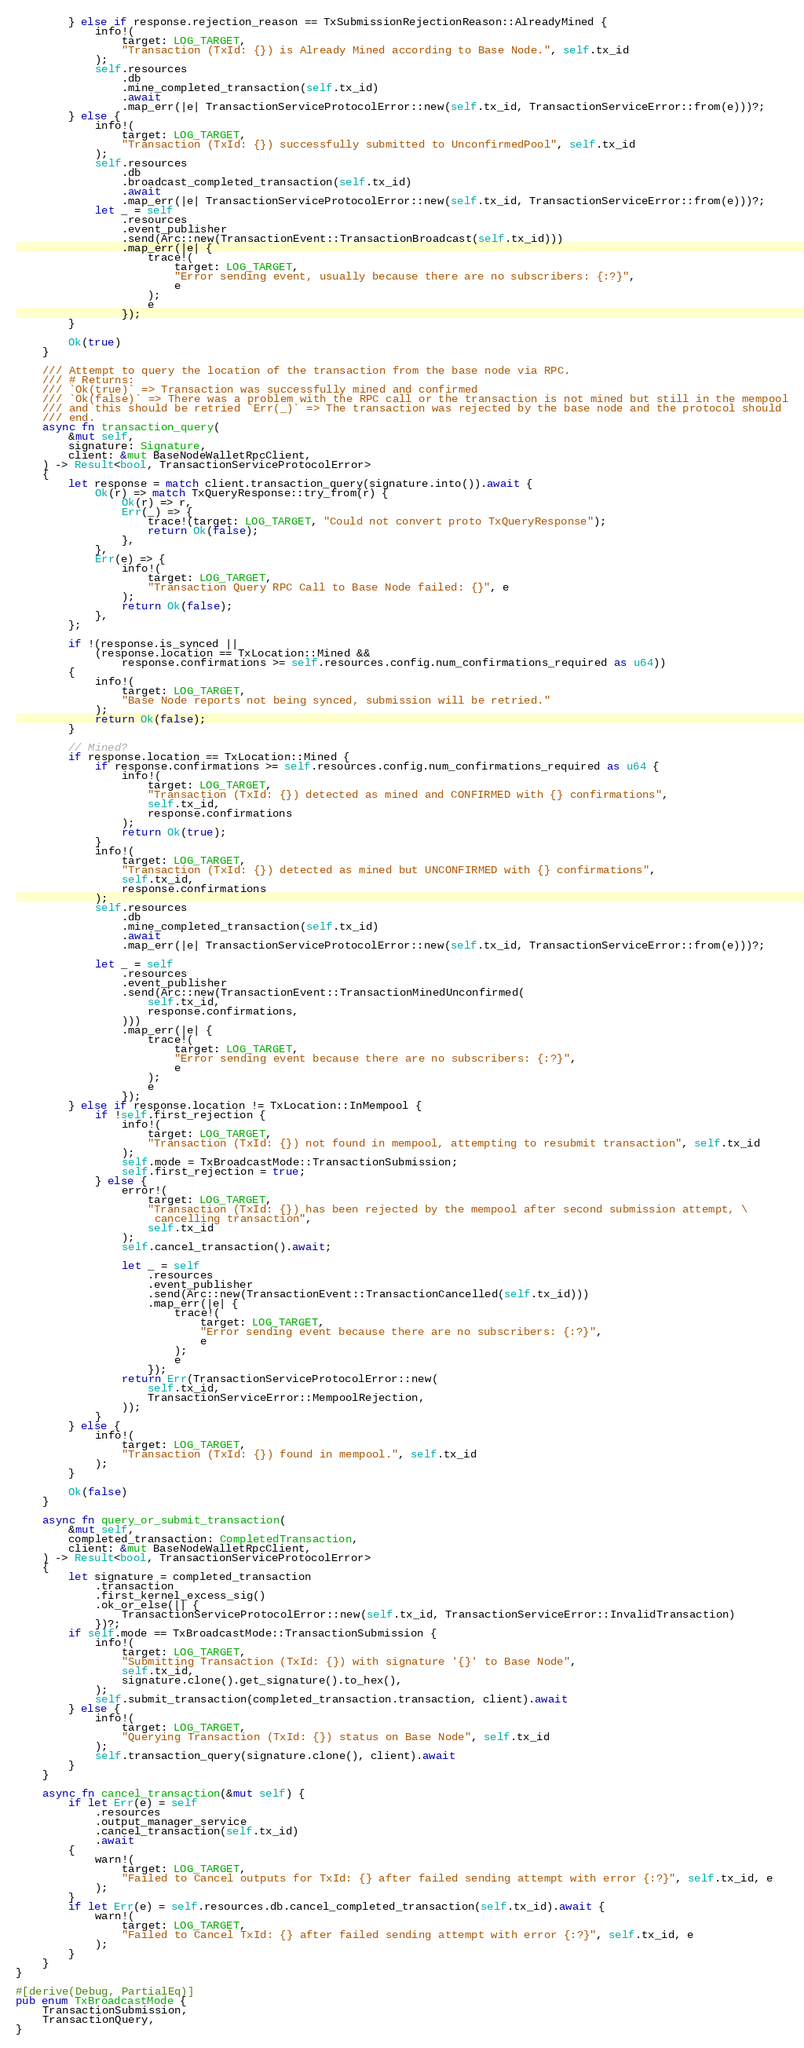<code> <loc_0><loc_0><loc_500><loc_500><_Rust_>        } else if response.rejection_reason == TxSubmissionRejectionReason::AlreadyMined {
            info!(
                target: LOG_TARGET,
                "Transaction (TxId: {}) is Already Mined according to Base Node.", self.tx_id
            );
            self.resources
                .db
                .mine_completed_transaction(self.tx_id)
                .await
                .map_err(|e| TransactionServiceProtocolError::new(self.tx_id, TransactionServiceError::from(e)))?;
        } else {
            info!(
                target: LOG_TARGET,
                "Transaction (TxId: {}) successfully submitted to UnconfirmedPool", self.tx_id
            );
            self.resources
                .db
                .broadcast_completed_transaction(self.tx_id)
                .await
                .map_err(|e| TransactionServiceProtocolError::new(self.tx_id, TransactionServiceError::from(e)))?;
            let _ = self
                .resources
                .event_publisher
                .send(Arc::new(TransactionEvent::TransactionBroadcast(self.tx_id)))
                .map_err(|e| {
                    trace!(
                        target: LOG_TARGET,
                        "Error sending event, usually because there are no subscribers: {:?}",
                        e
                    );
                    e
                });
        }

        Ok(true)
    }

    /// Attempt to query the location of the transaction from the base node via RPC.
    /// # Returns:
    /// `Ok(true)` => Transaction was successfully mined and confirmed
    /// `Ok(false)` => There was a problem with the RPC call or the transaction is not mined but still in the mempool
    /// and this should be retried `Err(_)` => The transaction was rejected by the base node and the protocol should
    /// end.
    async fn transaction_query(
        &mut self,
        signature: Signature,
        client: &mut BaseNodeWalletRpcClient,
    ) -> Result<bool, TransactionServiceProtocolError>
    {
        let response = match client.transaction_query(signature.into()).await {
            Ok(r) => match TxQueryResponse::try_from(r) {
                Ok(r) => r,
                Err(_) => {
                    trace!(target: LOG_TARGET, "Could not convert proto TxQueryResponse");
                    return Ok(false);
                },
            },
            Err(e) => {
                info!(
                    target: LOG_TARGET,
                    "Transaction Query RPC Call to Base Node failed: {}", e
                );
                return Ok(false);
            },
        };

        if !(response.is_synced ||
            (response.location == TxLocation::Mined &&
                response.confirmations >= self.resources.config.num_confirmations_required as u64))
        {
            info!(
                target: LOG_TARGET,
                "Base Node reports not being synced, submission will be retried."
            );
            return Ok(false);
        }

        // Mined?
        if response.location == TxLocation::Mined {
            if response.confirmations >= self.resources.config.num_confirmations_required as u64 {
                info!(
                    target: LOG_TARGET,
                    "Transaction (TxId: {}) detected as mined and CONFIRMED with {} confirmations",
                    self.tx_id,
                    response.confirmations
                );
                return Ok(true);
            }
            info!(
                target: LOG_TARGET,
                "Transaction (TxId: {}) detected as mined but UNCONFIRMED with {} confirmations",
                self.tx_id,
                response.confirmations
            );
            self.resources
                .db
                .mine_completed_transaction(self.tx_id)
                .await
                .map_err(|e| TransactionServiceProtocolError::new(self.tx_id, TransactionServiceError::from(e)))?;

            let _ = self
                .resources
                .event_publisher
                .send(Arc::new(TransactionEvent::TransactionMinedUnconfirmed(
                    self.tx_id,
                    response.confirmations,
                )))
                .map_err(|e| {
                    trace!(
                        target: LOG_TARGET,
                        "Error sending event because there are no subscribers: {:?}",
                        e
                    );
                    e
                });
        } else if response.location != TxLocation::InMempool {
            if !self.first_rejection {
                info!(
                    target: LOG_TARGET,
                    "Transaction (TxId: {}) not found in mempool, attempting to resubmit transaction", self.tx_id
                );
                self.mode = TxBroadcastMode::TransactionSubmission;
                self.first_rejection = true;
            } else {
                error!(
                    target: LOG_TARGET,
                    "Transaction (TxId: {}) has been rejected by the mempool after second submission attempt, \
                     cancelling transaction",
                    self.tx_id
                );
                self.cancel_transaction().await;

                let _ = self
                    .resources
                    .event_publisher
                    .send(Arc::new(TransactionEvent::TransactionCancelled(self.tx_id)))
                    .map_err(|e| {
                        trace!(
                            target: LOG_TARGET,
                            "Error sending event because there are no subscribers: {:?}",
                            e
                        );
                        e
                    });
                return Err(TransactionServiceProtocolError::new(
                    self.tx_id,
                    TransactionServiceError::MempoolRejection,
                ));
            }
        } else {
            info!(
                target: LOG_TARGET,
                "Transaction (TxId: {}) found in mempool.", self.tx_id
            );
        }

        Ok(false)
    }

    async fn query_or_submit_transaction(
        &mut self,
        completed_transaction: CompletedTransaction,
        client: &mut BaseNodeWalletRpcClient,
    ) -> Result<bool, TransactionServiceProtocolError>
    {
        let signature = completed_transaction
            .transaction
            .first_kernel_excess_sig()
            .ok_or_else(|| {
                TransactionServiceProtocolError::new(self.tx_id, TransactionServiceError::InvalidTransaction)
            })?;
        if self.mode == TxBroadcastMode::TransactionSubmission {
            info!(
                target: LOG_TARGET,
                "Submitting Transaction (TxId: {}) with signature '{}' to Base Node",
                self.tx_id,
                signature.clone().get_signature().to_hex(),
            );
            self.submit_transaction(completed_transaction.transaction, client).await
        } else {
            info!(
                target: LOG_TARGET,
                "Querying Transaction (TxId: {}) status on Base Node", self.tx_id
            );
            self.transaction_query(signature.clone(), client).await
        }
    }

    async fn cancel_transaction(&mut self) {
        if let Err(e) = self
            .resources
            .output_manager_service
            .cancel_transaction(self.tx_id)
            .await
        {
            warn!(
                target: LOG_TARGET,
                "Failed to Cancel outputs for TxId: {} after failed sending attempt with error {:?}", self.tx_id, e
            );
        }
        if let Err(e) = self.resources.db.cancel_completed_transaction(self.tx_id).await {
            warn!(
                target: LOG_TARGET,
                "Failed to Cancel TxId: {} after failed sending attempt with error {:?}", self.tx_id, e
            );
        }
    }
}

#[derive(Debug, PartialEq)]
pub enum TxBroadcastMode {
    TransactionSubmission,
    TransactionQuery,
}
</code> 